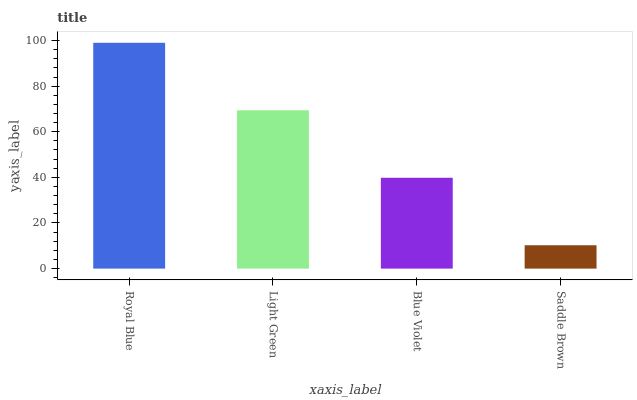Is Saddle Brown the minimum?
Answer yes or no. Yes. Is Royal Blue the maximum?
Answer yes or no. Yes. Is Light Green the minimum?
Answer yes or no. No. Is Light Green the maximum?
Answer yes or no. No. Is Royal Blue greater than Light Green?
Answer yes or no. Yes. Is Light Green less than Royal Blue?
Answer yes or no. Yes. Is Light Green greater than Royal Blue?
Answer yes or no. No. Is Royal Blue less than Light Green?
Answer yes or no. No. Is Light Green the high median?
Answer yes or no. Yes. Is Blue Violet the low median?
Answer yes or no. Yes. Is Royal Blue the high median?
Answer yes or no. No. Is Light Green the low median?
Answer yes or no. No. 